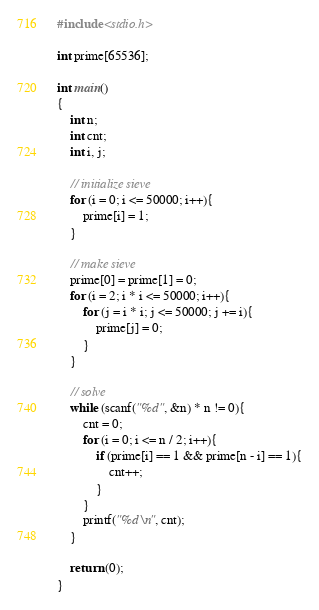Convert code to text. <code><loc_0><loc_0><loc_500><loc_500><_C_>#include <stdio.h>

int prime[65536];

int main()
{
    int n;
    int cnt;
    int i, j;

    // initialize sieve
    for (i = 0; i <= 50000; i++){
        prime[i] = 1;
    }

    // make sieve
    prime[0] = prime[1] = 0;
    for (i = 2; i * i <= 50000; i++){
        for (j = i * i; j <= 50000; j += i){
            prime[j] = 0;
        }
    }

    // solve
    while (scanf("%d", &n) * n != 0){
        cnt = 0;
        for (i = 0; i <= n / 2; i++){
            if (prime[i] == 1 && prime[n - i] == 1){
                cnt++;
            }
        }
        printf("%d\n", cnt);
    }

    return (0);
}</code> 